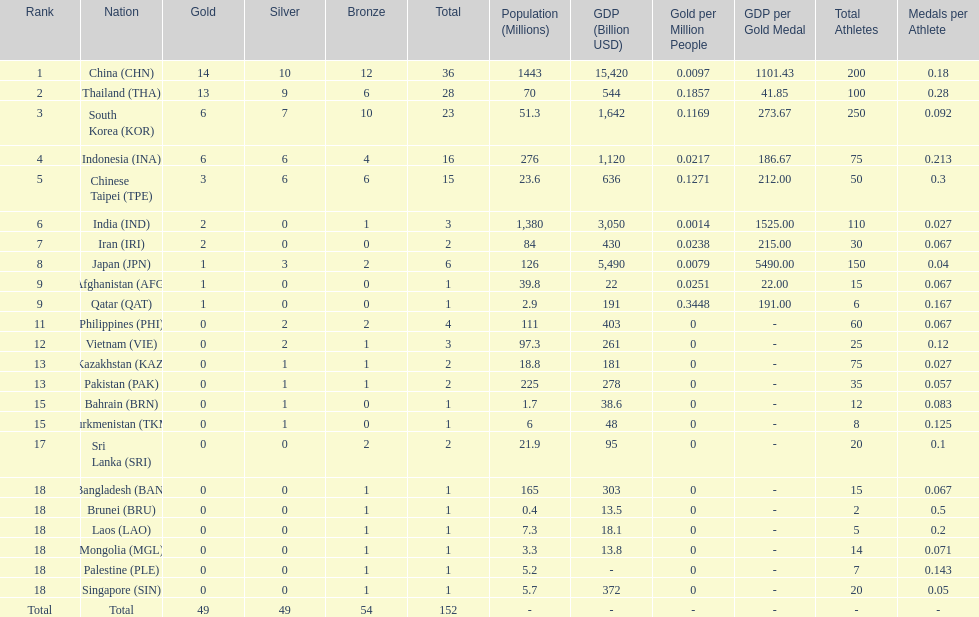How many nations received a medal in each gold, silver, and bronze? 6. 